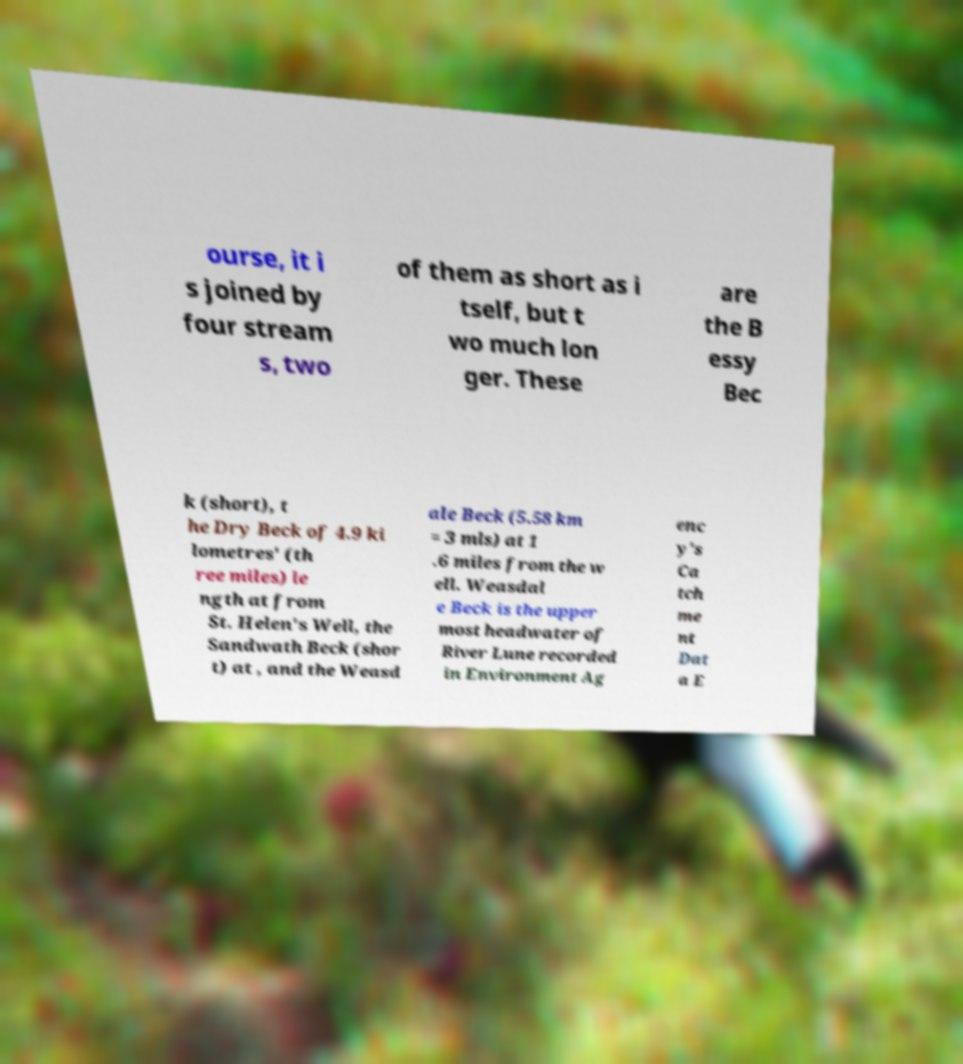There's text embedded in this image that I need extracted. Can you transcribe it verbatim? ourse, it i s joined by four stream s, two of them as short as i tself, but t wo much lon ger. These are the B essy Bec k (short), t he Dry Beck of 4.9 ki lometres' (th ree miles) le ngth at from St. Helen's Well, the Sandwath Beck (shor t) at , and the Weasd ale Beck (5.58 km = 3 mls) at 1 .6 miles from the w ell. Weasdal e Beck is the upper most headwater of River Lune recorded in Environment Ag enc y's Ca tch me nt Dat a E 